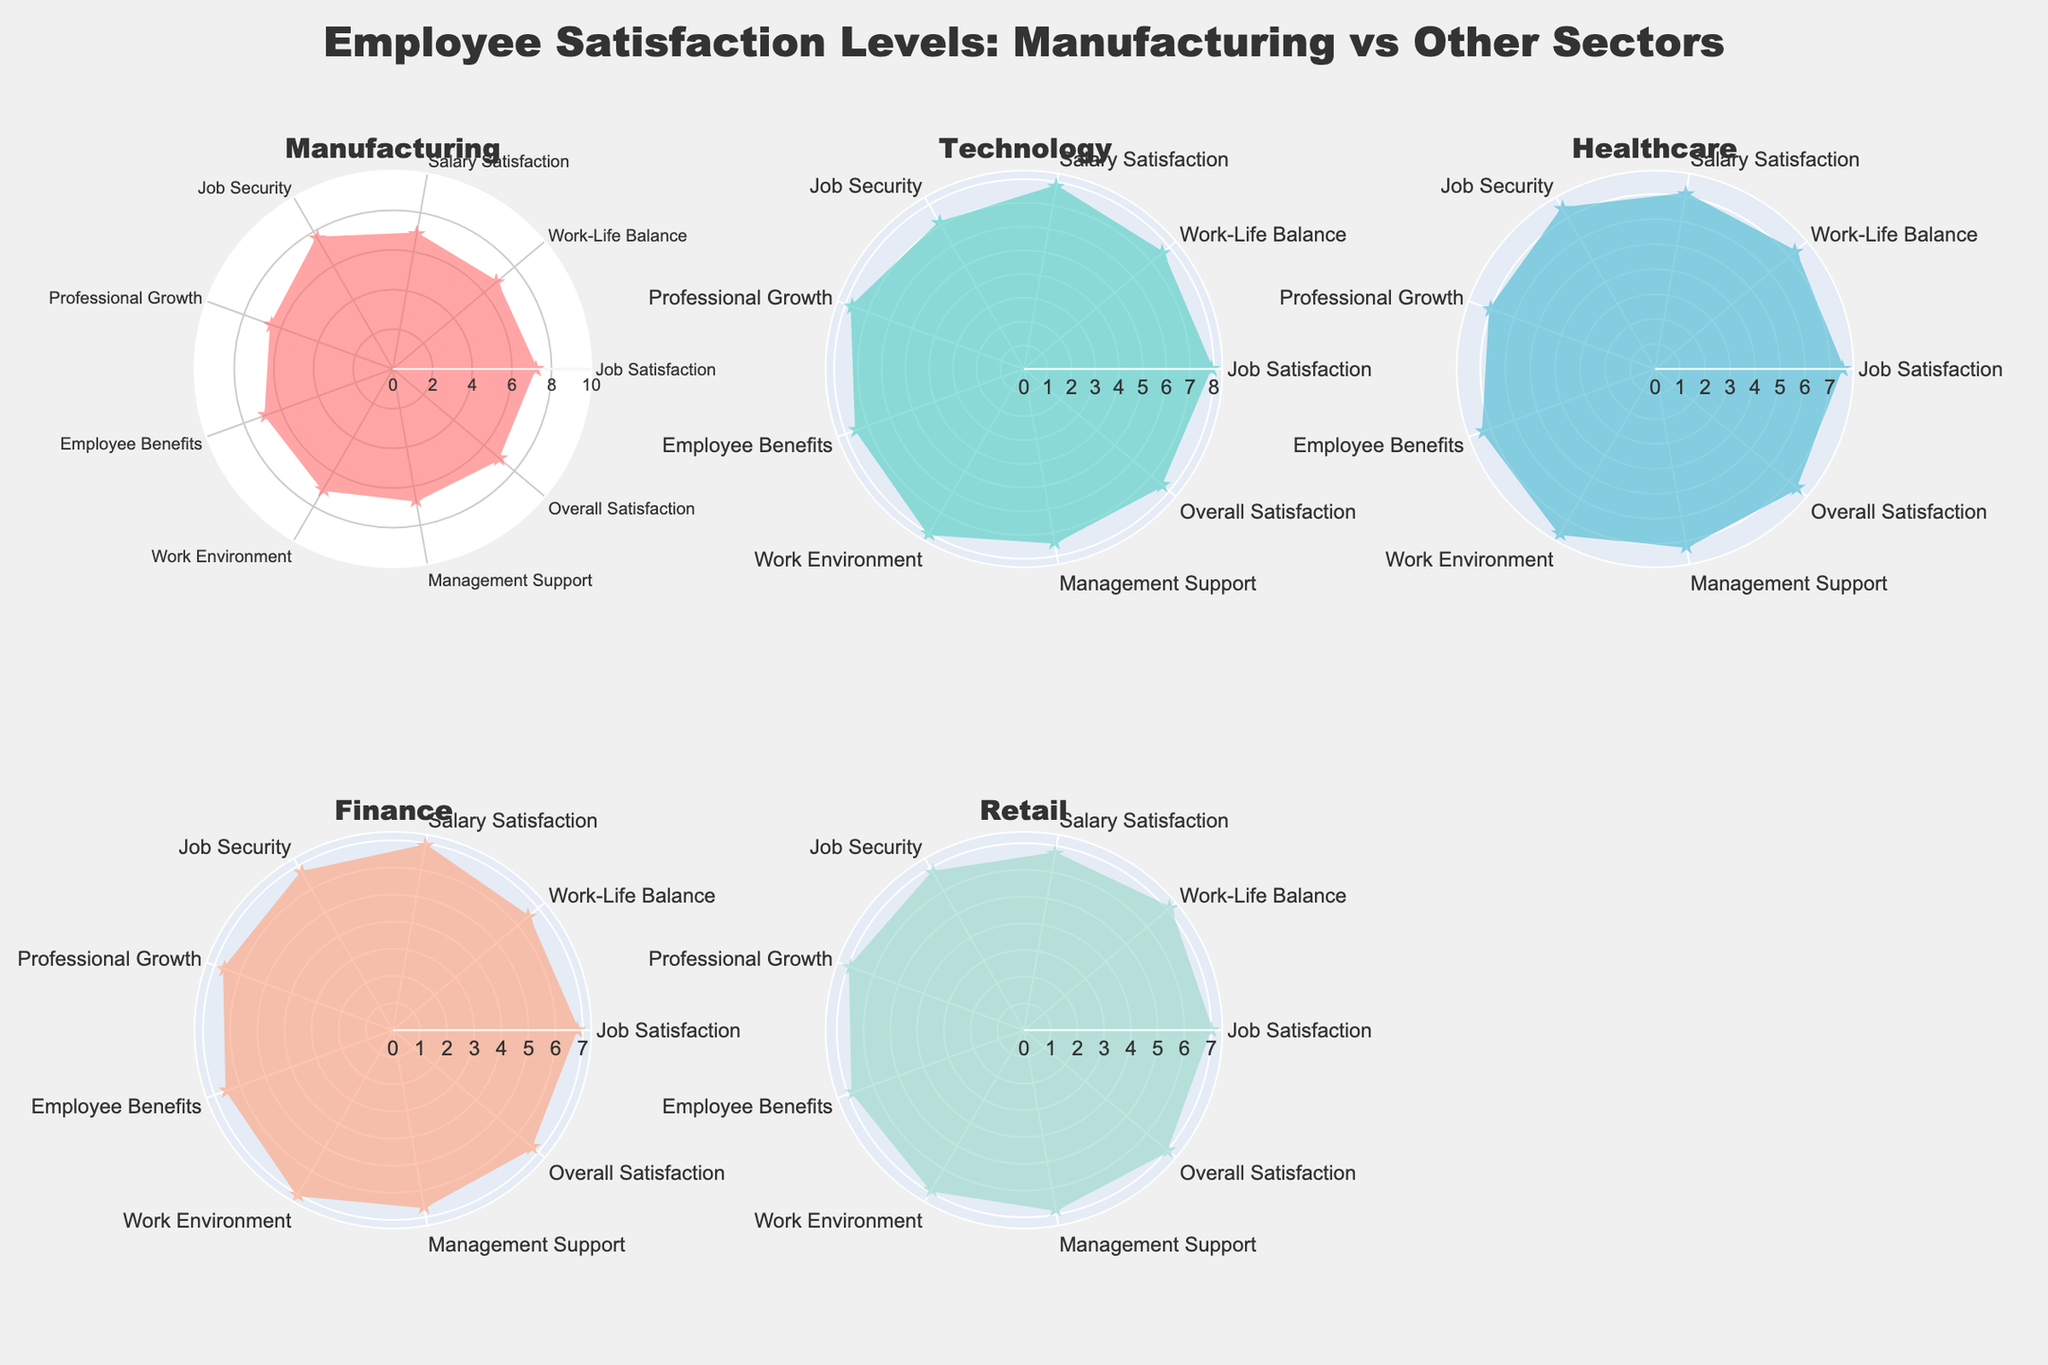What is the title of the chart? The title is located at the top center of the chart. It reads "Employee Satisfaction Levels: Manufacturing vs Other Sectors".
Answer: Employee Satisfaction Levels: Manufacturing vs Other Sectors Which sector shows the highest job satisfaction? By looking at the radar chart for each sector, Technology has the highest job satisfaction score of 7.9.
Answer: Technology How does Manufacturing compare to Retail in terms of job security? By comparing the radial values for Job Security in the Manufacturing and Retail sectors, you can see that Manufacturing has a higher score of 7.6 compared to Retail's 6.8.
Answer: Manufacturing has higher job security What is the average salary satisfaction score across all sectors? The salary satisfaction scores are: Manufacturing (6.9), Technology (7.8), Healthcare (7.1), Finance (6.9), and Retail (6.7). Adding them: 6.9 + 7.8 + 7.1 + 6.9 + 6.7 = 35.4. Dividing by 5 sectors gives an average of 35.4/5 = 7.08.
Answer: 7.08 Which sector has the lowest overall satisfaction? By comparing the Overall Satisfaction scores for all sectors, Finance has the lowest overall satisfaction score of 6.7.
Answer: Finance Is work-life balance better in Healthcare or Manufacturing? By looking at the work-life balance scores on the radar charts, Healthcare has a score of 7.3, whereas Manufacturing has a score of 6.8, indicating better work-life balance in Healthcare.
Answer: Healthcare Which sector has the most balanced satisfaction levels across all categories? Analyze the radar charts visually to see which sector has the most evenly spread satisfaction levels across categories. Technology has fairly consistent and high scores across all categories, indicating balanced satisfaction levels.
Answer: Technology What is the difference in salary satisfaction between Technology and Retail? The salary satisfaction score for Technology is 7.8 while for Retail it is 6.7. The difference is 7.8 - 6.7 = 1.1.
Answer: 1.1 Which metric shows the greatest variability across all sectors? Visually, Professional Growth shows a significant variability, with scores ranging from 6.5 in Manufacturing to 7.7 in Technology.
Answer: Professional Growth How does Manufacturing compare to Finance in terms of management support? Looking at the radar chart for the management support category, Manufacturing has a score of 6.7, whereas Finance has a score of 6.6. Thus, Manufacturing has slightly better management support.
Answer: Manufacturing has slightly better management support 